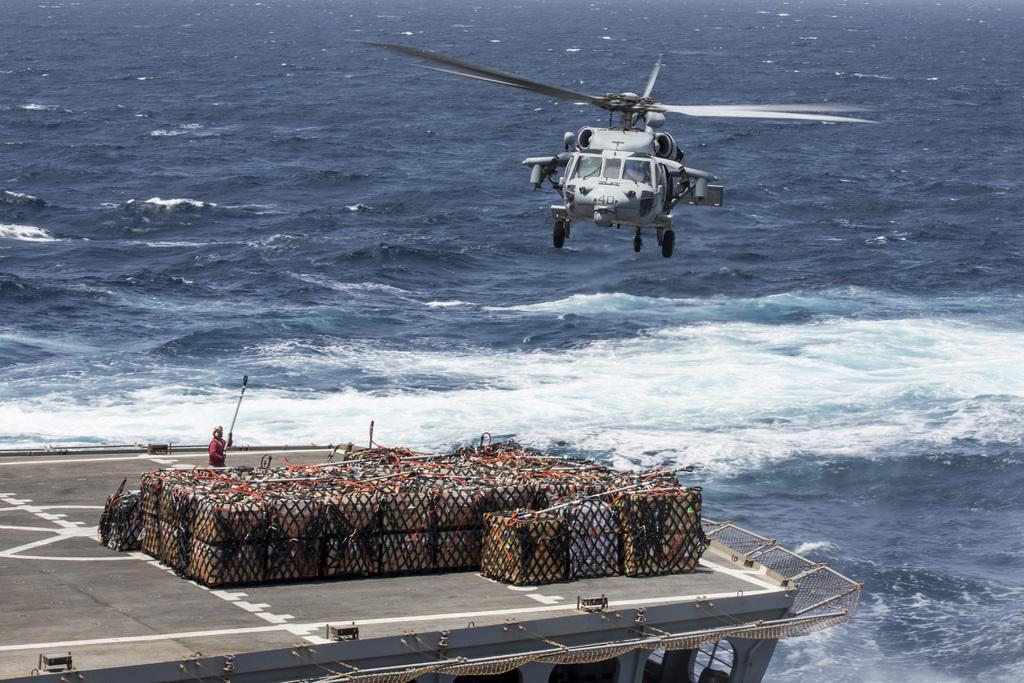How would you summarize this image in a sentence or two? In the foreground I can see a boat, boxes and a person. On the top I can see a helicopter. In the background I can see the ocean. This image is taken during a day. 